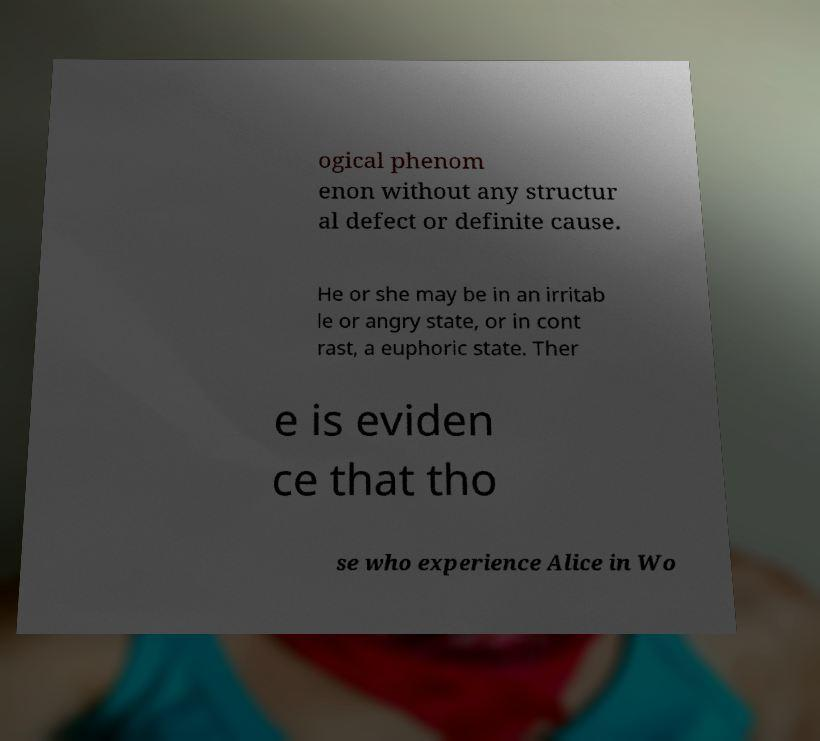I need the written content from this picture converted into text. Can you do that? ogical phenom enon without any structur al defect or definite cause. He or she may be in an irritab le or angry state, or in cont rast, a euphoric state. Ther e is eviden ce that tho se who experience Alice in Wo 